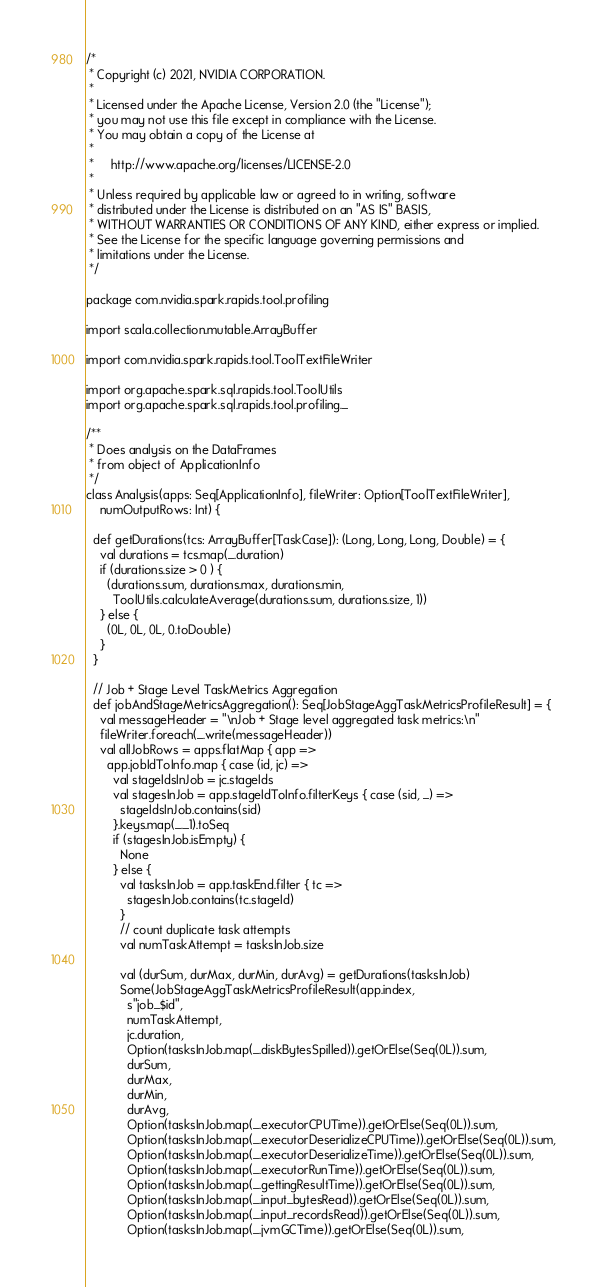Convert code to text. <code><loc_0><loc_0><loc_500><loc_500><_Scala_>/*
 * Copyright (c) 2021, NVIDIA CORPORATION.
 *
 * Licensed under the Apache License, Version 2.0 (the "License");
 * you may not use this file except in compliance with the License.
 * You may obtain a copy of the License at
 *
 *     http://www.apache.org/licenses/LICENSE-2.0
 *
 * Unless required by applicable law or agreed to in writing, software
 * distributed under the License is distributed on an "AS IS" BASIS,
 * WITHOUT WARRANTIES OR CONDITIONS OF ANY KIND, either express or implied.
 * See the License for the specific language governing permissions and
 * limitations under the License.
 */

package com.nvidia.spark.rapids.tool.profiling

import scala.collection.mutable.ArrayBuffer

import com.nvidia.spark.rapids.tool.ToolTextFileWriter

import org.apache.spark.sql.rapids.tool.ToolUtils
import org.apache.spark.sql.rapids.tool.profiling._

/**
 * Does analysis on the DataFrames
 * from object of ApplicationInfo
 */
class Analysis(apps: Seq[ApplicationInfo], fileWriter: Option[ToolTextFileWriter],
    numOutputRows: Int) {

  def getDurations(tcs: ArrayBuffer[TaskCase]): (Long, Long, Long, Double) = {
    val durations = tcs.map(_.duration)
    if (durations.size > 0 ) {
      (durations.sum, durations.max, durations.min,
        ToolUtils.calculateAverage(durations.sum, durations.size, 1))
    } else {
      (0L, 0L, 0L, 0.toDouble)
    }
  }

  // Job + Stage Level TaskMetrics Aggregation
  def jobAndStageMetricsAggregation(): Seq[JobStageAggTaskMetricsProfileResult] = {
    val messageHeader = "\nJob + Stage level aggregated task metrics:\n"
    fileWriter.foreach(_.write(messageHeader))
    val allJobRows = apps.flatMap { app =>
      app.jobIdToInfo.map { case (id, jc) =>
        val stageIdsInJob = jc.stageIds
        val stagesInJob = app.stageIdToInfo.filterKeys { case (sid, _) =>
          stageIdsInJob.contains(sid)
        }.keys.map(_._1).toSeq
        if (stagesInJob.isEmpty) {
          None
        } else {
          val tasksInJob = app.taskEnd.filter { tc =>
            stagesInJob.contains(tc.stageId)
          }
          // count duplicate task attempts
          val numTaskAttempt = tasksInJob.size

          val (durSum, durMax, durMin, durAvg) = getDurations(tasksInJob)
          Some(JobStageAggTaskMetricsProfileResult(app.index,
            s"job_$id",
            numTaskAttempt,
            jc.duration,
            Option(tasksInJob.map(_.diskBytesSpilled)).getOrElse(Seq(0L)).sum,
            durSum,
            durMax,
            durMin,
            durAvg,
            Option(tasksInJob.map(_.executorCPUTime)).getOrElse(Seq(0L)).sum,
            Option(tasksInJob.map(_.executorDeserializeCPUTime)).getOrElse(Seq(0L)).sum,
            Option(tasksInJob.map(_.executorDeserializeTime)).getOrElse(Seq(0L)).sum,
            Option(tasksInJob.map(_.executorRunTime)).getOrElse(Seq(0L)).sum,
            Option(tasksInJob.map(_.gettingResultTime)).getOrElse(Seq(0L)).sum,
            Option(tasksInJob.map(_.input_bytesRead)).getOrElse(Seq(0L)).sum,
            Option(tasksInJob.map(_.input_recordsRead)).getOrElse(Seq(0L)).sum,
            Option(tasksInJob.map(_.jvmGCTime)).getOrElse(Seq(0L)).sum,</code> 